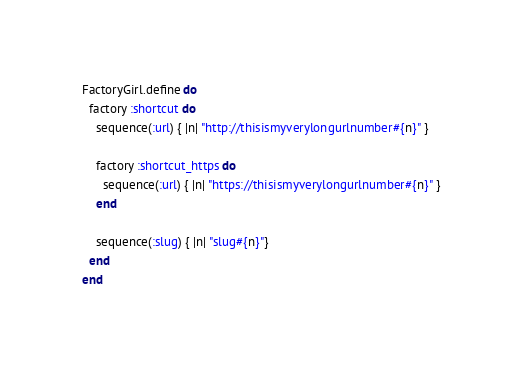Convert code to text. <code><loc_0><loc_0><loc_500><loc_500><_Ruby_>FactoryGirl.define do
  factory :shortcut do
    sequence(:url) { |n| "http://thisismyverylongurlnumber#{n}" }

    factory :shortcut_https do
      sequence(:url) { |n| "https://thisismyverylongurlnumber#{n}" }
    end

    sequence(:slug) { |n| "slug#{n}"}
  end
end
</code> 